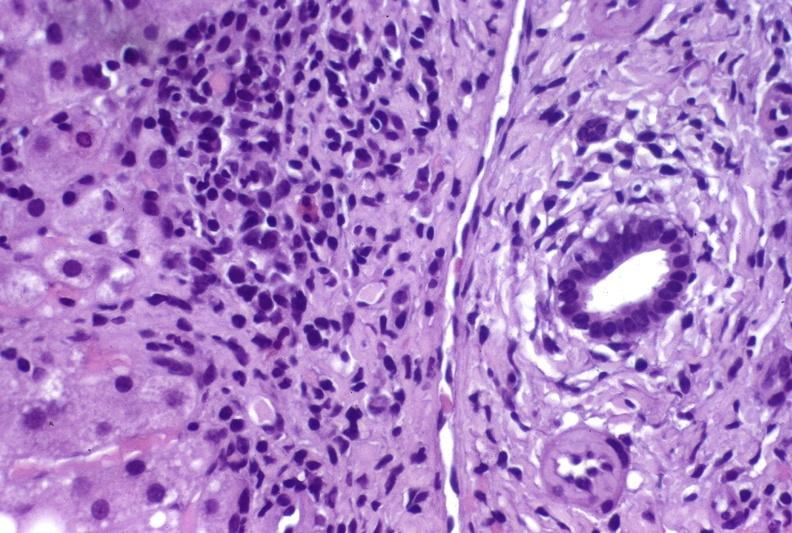s left ventricle hypertrophy present?
Answer the question using a single word or phrase. No 